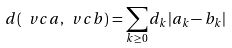Convert formula to latex. <formula><loc_0><loc_0><loc_500><loc_500>d ( \ v c { a } , \ v c { b } ) = \sum _ { k \geq 0 } d _ { k } | a _ { k } - b _ { k } |</formula> 